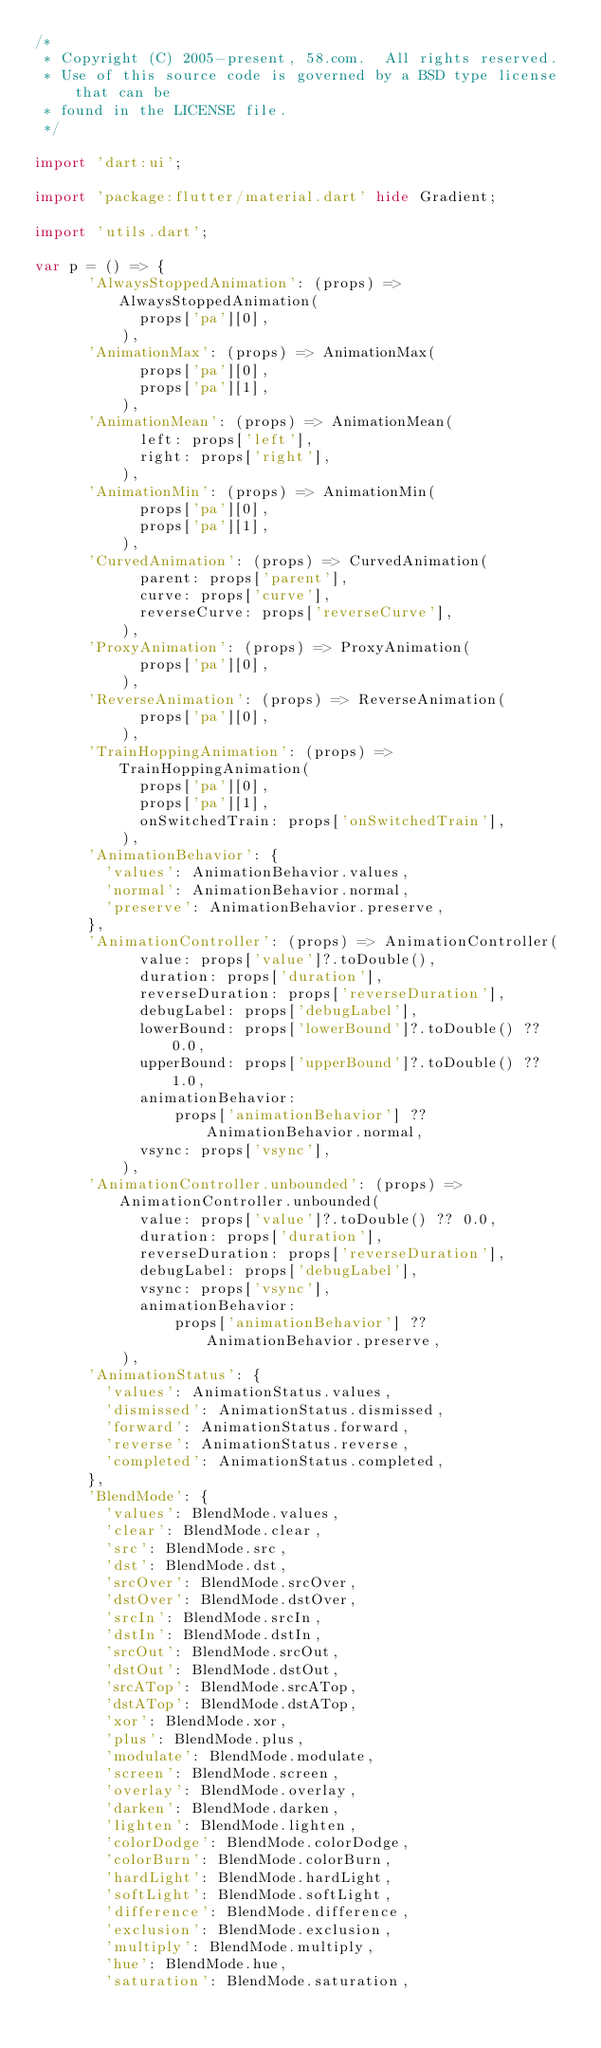<code> <loc_0><loc_0><loc_500><loc_500><_Dart_>/*
 * Copyright (C) 2005-present, 58.com.  All rights reserved.
 * Use of this source code is governed by a BSD type license that can be
 * found in the LICENSE file.
 */

import 'dart:ui';

import 'package:flutter/material.dart' hide Gradient;

import 'utils.dart';

var p = () => {
      'AlwaysStoppedAnimation': (props) => AlwaysStoppedAnimation(
            props['pa'][0],
          ),
      'AnimationMax': (props) => AnimationMax(
            props['pa'][0],
            props['pa'][1],
          ),
      'AnimationMean': (props) => AnimationMean(
            left: props['left'],
            right: props['right'],
          ),
      'AnimationMin': (props) => AnimationMin(
            props['pa'][0],
            props['pa'][1],
          ),
      'CurvedAnimation': (props) => CurvedAnimation(
            parent: props['parent'],
            curve: props['curve'],
            reverseCurve: props['reverseCurve'],
          ),
      'ProxyAnimation': (props) => ProxyAnimation(
            props['pa'][0],
          ),
      'ReverseAnimation': (props) => ReverseAnimation(
            props['pa'][0],
          ),
      'TrainHoppingAnimation': (props) => TrainHoppingAnimation(
            props['pa'][0],
            props['pa'][1],
            onSwitchedTrain: props['onSwitchedTrain'],
          ),
      'AnimationBehavior': {
        'values': AnimationBehavior.values,
        'normal': AnimationBehavior.normal,
        'preserve': AnimationBehavior.preserve,
      },
      'AnimationController': (props) => AnimationController(
            value: props['value']?.toDouble(),
            duration: props['duration'],
            reverseDuration: props['reverseDuration'],
            debugLabel: props['debugLabel'],
            lowerBound: props['lowerBound']?.toDouble() ?? 0.0,
            upperBound: props['upperBound']?.toDouble() ?? 1.0,
            animationBehavior:
                props['animationBehavior'] ?? AnimationBehavior.normal,
            vsync: props['vsync'],
          ),
      'AnimationController.unbounded': (props) => AnimationController.unbounded(
            value: props['value']?.toDouble() ?? 0.0,
            duration: props['duration'],
            reverseDuration: props['reverseDuration'],
            debugLabel: props['debugLabel'],
            vsync: props['vsync'],
            animationBehavior:
                props['animationBehavior'] ?? AnimationBehavior.preserve,
          ),
      'AnimationStatus': {
        'values': AnimationStatus.values,
        'dismissed': AnimationStatus.dismissed,
        'forward': AnimationStatus.forward,
        'reverse': AnimationStatus.reverse,
        'completed': AnimationStatus.completed,
      },
      'BlendMode': {
        'values': BlendMode.values,
        'clear': BlendMode.clear,
        'src': BlendMode.src,
        'dst': BlendMode.dst,
        'srcOver': BlendMode.srcOver,
        'dstOver': BlendMode.dstOver,
        'srcIn': BlendMode.srcIn,
        'dstIn': BlendMode.dstIn,
        'srcOut': BlendMode.srcOut,
        'dstOut': BlendMode.dstOut,
        'srcATop': BlendMode.srcATop,
        'dstATop': BlendMode.dstATop,
        'xor': BlendMode.xor,
        'plus': BlendMode.plus,
        'modulate': BlendMode.modulate,
        'screen': BlendMode.screen,
        'overlay': BlendMode.overlay,
        'darken': BlendMode.darken,
        'lighten': BlendMode.lighten,
        'colorDodge': BlendMode.colorDodge,
        'colorBurn': BlendMode.colorBurn,
        'hardLight': BlendMode.hardLight,
        'softLight': BlendMode.softLight,
        'difference': BlendMode.difference,
        'exclusion': BlendMode.exclusion,
        'multiply': BlendMode.multiply,
        'hue': BlendMode.hue,
        'saturation': BlendMode.saturation,</code> 